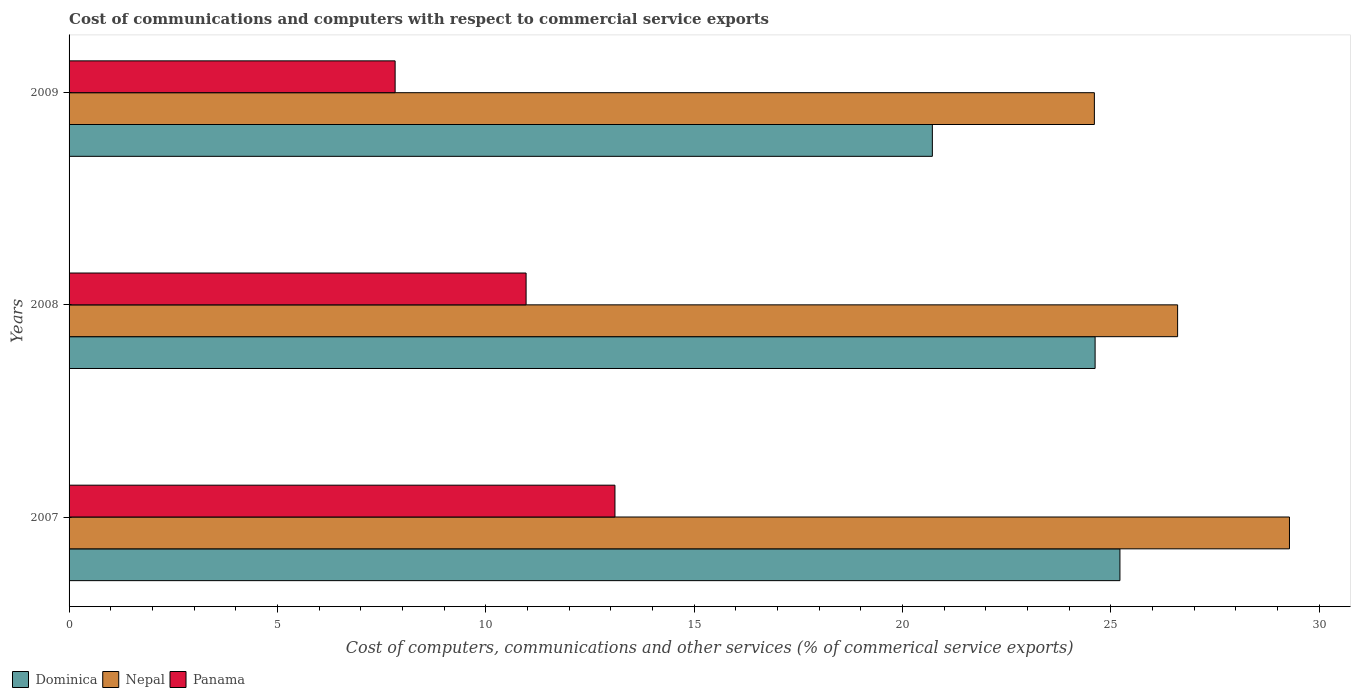How many different coloured bars are there?
Offer a very short reply. 3. How many groups of bars are there?
Offer a terse response. 3. Are the number of bars per tick equal to the number of legend labels?
Offer a very short reply. Yes. Are the number of bars on each tick of the Y-axis equal?
Give a very brief answer. Yes. How many bars are there on the 1st tick from the bottom?
Keep it short and to the point. 3. What is the label of the 1st group of bars from the top?
Ensure brevity in your answer.  2009. In how many cases, is the number of bars for a given year not equal to the number of legend labels?
Offer a terse response. 0. What is the cost of communications and computers in Panama in 2008?
Offer a very short reply. 10.97. Across all years, what is the maximum cost of communications and computers in Nepal?
Offer a very short reply. 29.29. Across all years, what is the minimum cost of communications and computers in Dominica?
Keep it short and to the point. 20.72. In which year was the cost of communications and computers in Dominica minimum?
Make the answer very short. 2009. What is the total cost of communications and computers in Panama in the graph?
Ensure brevity in your answer.  31.89. What is the difference between the cost of communications and computers in Panama in 2007 and that in 2009?
Your answer should be compact. 5.28. What is the difference between the cost of communications and computers in Panama in 2008 and the cost of communications and computers in Dominica in 2007?
Your answer should be very brief. -14.25. What is the average cost of communications and computers in Dominica per year?
Provide a succinct answer. 23.52. In the year 2008, what is the difference between the cost of communications and computers in Panama and cost of communications and computers in Nepal?
Provide a succinct answer. -15.64. In how many years, is the cost of communications and computers in Dominica greater than 24 %?
Give a very brief answer. 2. What is the ratio of the cost of communications and computers in Nepal in 2008 to that in 2009?
Provide a short and direct response. 1.08. What is the difference between the highest and the second highest cost of communications and computers in Dominica?
Offer a very short reply. 0.6. What is the difference between the highest and the lowest cost of communications and computers in Dominica?
Offer a very short reply. 4.5. In how many years, is the cost of communications and computers in Dominica greater than the average cost of communications and computers in Dominica taken over all years?
Provide a succinct answer. 2. What does the 2nd bar from the top in 2007 represents?
Give a very brief answer. Nepal. What does the 2nd bar from the bottom in 2008 represents?
Give a very brief answer. Nepal. How many years are there in the graph?
Your answer should be very brief. 3. Does the graph contain grids?
Give a very brief answer. No. Where does the legend appear in the graph?
Offer a very short reply. Bottom left. What is the title of the graph?
Provide a short and direct response. Cost of communications and computers with respect to commercial service exports. What is the label or title of the X-axis?
Ensure brevity in your answer.  Cost of computers, communications and other services (% of commerical service exports). What is the Cost of computers, communications and other services (% of commerical service exports) of Dominica in 2007?
Offer a very short reply. 25.22. What is the Cost of computers, communications and other services (% of commerical service exports) in Nepal in 2007?
Offer a terse response. 29.29. What is the Cost of computers, communications and other services (% of commerical service exports) of Panama in 2007?
Ensure brevity in your answer.  13.1. What is the Cost of computers, communications and other services (% of commerical service exports) in Dominica in 2008?
Ensure brevity in your answer.  24.62. What is the Cost of computers, communications and other services (% of commerical service exports) in Nepal in 2008?
Provide a short and direct response. 26.6. What is the Cost of computers, communications and other services (% of commerical service exports) in Panama in 2008?
Your answer should be very brief. 10.97. What is the Cost of computers, communications and other services (% of commerical service exports) in Dominica in 2009?
Your answer should be very brief. 20.72. What is the Cost of computers, communications and other services (% of commerical service exports) of Nepal in 2009?
Provide a succinct answer. 24.61. What is the Cost of computers, communications and other services (% of commerical service exports) in Panama in 2009?
Offer a very short reply. 7.83. Across all years, what is the maximum Cost of computers, communications and other services (% of commerical service exports) in Dominica?
Your answer should be very brief. 25.22. Across all years, what is the maximum Cost of computers, communications and other services (% of commerical service exports) in Nepal?
Your answer should be very brief. 29.29. Across all years, what is the maximum Cost of computers, communications and other services (% of commerical service exports) in Panama?
Make the answer very short. 13.1. Across all years, what is the minimum Cost of computers, communications and other services (% of commerical service exports) of Dominica?
Make the answer very short. 20.72. Across all years, what is the minimum Cost of computers, communications and other services (% of commerical service exports) in Nepal?
Make the answer very short. 24.61. Across all years, what is the minimum Cost of computers, communications and other services (% of commerical service exports) in Panama?
Ensure brevity in your answer.  7.83. What is the total Cost of computers, communications and other services (% of commerical service exports) in Dominica in the graph?
Offer a very short reply. 70.56. What is the total Cost of computers, communications and other services (% of commerical service exports) of Nepal in the graph?
Give a very brief answer. 80.5. What is the total Cost of computers, communications and other services (% of commerical service exports) in Panama in the graph?
Offer a very short reply. 31.89. What is the difference between the Cost of computers, communications and other services (% of commerical service exports) of Dominica in 2007 and that in 2008?
Ensure brevity in your answer.  0.6. What is the difference between the Cost of computers, communications and other services (% of commerical service exports) in Nepal in 2007 and that in 2008?
Offer a terse response. 2.68. What is the difference between the Cost of computers, communications and other services (% of commerical service exports) in Panama in 2007 and that in 2008?
Make the answer very short. 2.13. What is the difference between the Cost of computers, communications and other services (% of commerical service exports) of Dominica in 2007 and that in 2009?
Your answer should be very brief. 4.5. What is the difference between the Cost of computers, communications and other services (% of commerical service exports) of Nepal in 2007 and that in 2009?
Your answer should be compact. 4.68. What is the difference between the Cost of computers, communications and other services (% of commerical service exports) in Panama in 2007 and that in 2009?
Your response must be concise. 5.28. What is the difference between the Cost of computers, communications and other services (% of commerical service exports) in Dominica in 2008 and that in 2009?
Make the answer very short. 3.91. What is the difference between the Cost of computers, communications and other services (% of commerical service exports) of Nepal in 2008 and that in 2009?
Provide a succinct answer. 2. What is the difference between the Cost of computers, communications and other services (% of commerical service exports) of Panama in 2008 and that in 2009?
Give a very brief answer. 3.14. What is the difference between the Cost of computers, communications and other services (% of commerical service exports) of Dominica in 2007 and the Cost of computers, communications and other services (% of commerical service exports) of Nepal in 2008?
Make the answer very short. -1.38. What is the difference between the Cost of computers, communications and other services (% of commerical service exports) in Dominica in 2007 and the Cost of computers, communications and other services (% of commerical service exports) in Panama in 2008?
Your response must be concise. 14.25. What is the difference between the Cost of computers, communications and other services (% of commerical service exports) of Nepal in 2007 and the Cost of computers, communications and other services (% of commerical service exports) of Panama in 2008?
Offer a terse response. 18.32. What is the difference between the Cost of computers, communications and other services (% of commerical service exports) of Dominica in 2007 and the Cost of computers, communications and other services (% of commerical service exports) of Nepal in 2009?
Ensure brevity in your answer.  0.61. What is the difference between the Cost of computers, communications and other services (% of commerical service exports) in Dominica in 2007 and the Cost of computers, communications and other services (% of commerical service exports) in Panama in 2009?
Your answer should be very brief. 17.39. What is the difference between the Cost of computers, communications and other services (% of commerical service exports) in Nepal in 2007 and the Cost of computers, communications and other services (% of commerical service exports) in Panama in 2009?
Offer a terse response. 21.46. What is the difference between the Cost of computers, communications and other services (% of commerical service exports) in Dominica in 2008 and the Cost of computers, communications and other services (% of commerical service exports) in Nepal in 2009?
Keep it short and to the point. 0.02. What is the difference between the Cost of computers, communications and other services (% of commerical service exports) in Dominica in 2008 and the Cost of computers, communications and other services (% of commerical service exports) in Panama in 2009?
Your answer should be compact. 16.8. What is the difference between the Cost of computers, communications and other services (% of commerical service exports) in Nepal in 2008 and the Cost of computers, communications and other services (% of commerical service exports) in Panama in 2009?
Ensure brevity in your answer.  18.78. What is the average Cost of computers, communications and other services (% of commerical service exports) of Dominica per year?
Ensure brevity in your answer.  23.52. What is the average Cost of computers, communications and other services (% of commerical service exports) of Nepal per year?
Provide a succinct answer. 26.83. What is the average Cost of computers, communications and other services (% of commerical service exports) of Panama per year?
Offer a terse response. 10.63. In the year 2007, what is the difference between the Cost of computers, communications and other services (% of commerical service exports) in Dominica and Cost of computers, communications and other services (% of commerical service exports) in Nepal?
Make the answer very short. -4.07. In the year 2007, what is the difference between the Cost of computers, communications and other services (% of commerical service exports) in Dominica and Cost of computers, communications and other services (% of commerical service exports) in Panama?
Give a very brief answer. 12.12. In the year 2007, what is the difference between the Cost of computers, communications and other services (% of commerical service exports) in Nepal and Cost of computers, communications and other services (% of commerical service exports) in Panama?
Provide a succinct answer. 16.19. In the year 2008, what is the difference between the Cost of computers, communications and other services (% of commerical service exports) of Dominica and Cost of computers, communications and other services (% of commerical service exports) of Nepal?
Keep it short and to the point. -1.98. In the year 2008, what is the difference between the Cost of computers, communications and other services (% of commerical service exports) of Dominica and Cost of computers, communications and other services (% of commerical service exports) of Panama?
Your answer should be very brief. 13.66. In the year 2008, what is the difference between the Cost of computers, communications and other services (% of commerical service exports) of Nepal and Cost of computers, communications and other services (% of commerical service exports) of Panama?
Your answer should be compact. 15.64. In the year 2009, what is the difference between the Cost of computers, communications and other services (% of commerical service exports) of Dominica and Cost of computers, communications and other services (% of commerical service exports) of Nepal?
Ensure brevity in your answer.  -3.89. In the year 2009, what is the difference between the Cost of computers, communications and other services (% of commerical service exports) of Dominica and Cost of computers, communications and other services (% of commerical service exports) of Panama?
Ensure brevity in your answer.  12.89. In the year 2009, what is the difference between the Cost of computers, communications and other services (% of commerical service exports) in Nepal and Cost of computers, communications and other services (% of commerical service exports) in Panama?
Keep it short and to the point. 16.78. What is the ratio of the Cost of computers, communications and other services (% of commerical service exports) of Dominica in 2007 to that in 2008?
Keep it short and to the point. 1.02. What is the ratio of the Cost of computers, communications and other services (% of commerical service exports) of Nepal in 2007 to that in 2008?
Offer a terse response. 1.1. What is the ratio of the Cost of computers, communications and other services (% of commerical service exports) of Panama in 2007 to that in 2008?
Keep it short and to the point. 1.19. What is the ratio of the Cost of computers, communications and other services (% of commerical service exports) in Dominica in 2007 to that in 2009?
Offer a terse response. 1.22. What is the ratio of the Cost of computers, communications and other services (% of commerical service exports) in Nepal in 2007 to that in 2009?
Provide a succinct answer. 1.19. What is the ratio of the Cost of computers, communications and other services (% of commerical service exports) in Panama in 2007 to that in 2009?
Offer a very short reply. 1.67. What is the ratio of the Cost of computers, communications and other services (% of commerical service exports) in Dominica in 2008 to that in 2009?
Provide a succinct answer. 1.19. What is the ratio of the Cost of computers, communications and other services (% of commerical service exports) of Nepal in 2008 to that in 2009?
Your answer should be compact. 1.08. What is the ratio of the Cost of computers, communications and other services (% of commerical service exports) in Panama in 2008 to that in 2009?
Offer a very short reply. 1.4. What is the difference between the highest and the second highest Cost of computers, communications and other services (% of commerical service exports) in Dominica?
Offer a terse response. 0.6. What is the difference between the highest and the second highest Cost of computers, communications and other services (% of commerical service exports) of Nepal?
Provide a short and direct response. 2.68. What is the difference between the highest and the second highest Cost of computers, communications and other services (% of commerical service exports) in Panama?
Your answer should be very brief. 2.13. What is the difference between the highest and the lowest Cost of computers, communications and other services (% of commerical service exports) in Dominica?
Provide a succinct answer. 4.5. What is the difference between the highest and the lowest Cost of computers, communications and other services (% of commerical service exports) in Nepal?
Your answer should be compact. 4.68. What is the difference between the highest and the lowest Cost of computers, communications and other services (% of commerical service exports) of Panama?
Provide a short and direct response. 5.28. 